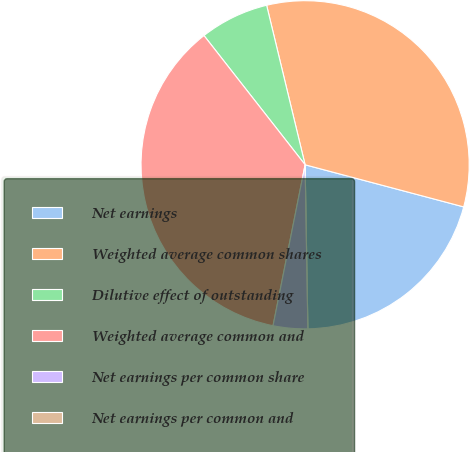Convert chart to OTSL. <chart><loc_0><loc_0><loc_500><loc_500><pie_chart><fcel>Net earnings<fcel>Weighted average common shares<fcel>Dilutive effect of outstanding<fcel>Weighted average common and<fcel>Net earnings per common share<fcel>Net earnings per common and<nl><fcel>20.6%<fcel>32.9%<fcel>6.8%<fcel>36.3%<fcel>3.4%<fcel>0.0%<nl></chart> 